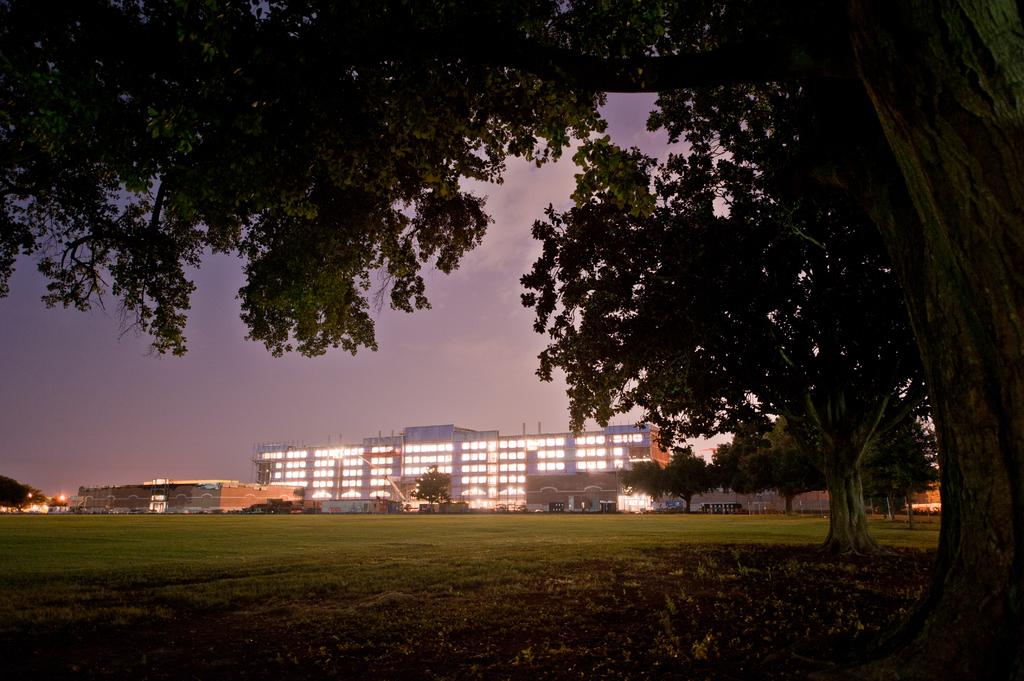What type of landscape is depicted in the image? There is a grassland in the image. What can be seen in the distance behind the grassland? There are buildings in the background of the image. What is visible in the sky in the image? The sky is visible in the background of the image. What type of vegetation is on the right side of the image? There are trees on the right side of the image. How does the society in the image wash their clothes? There is no society or washing activity depicted in the image; it features a grassland with buildings and trees in the background. 